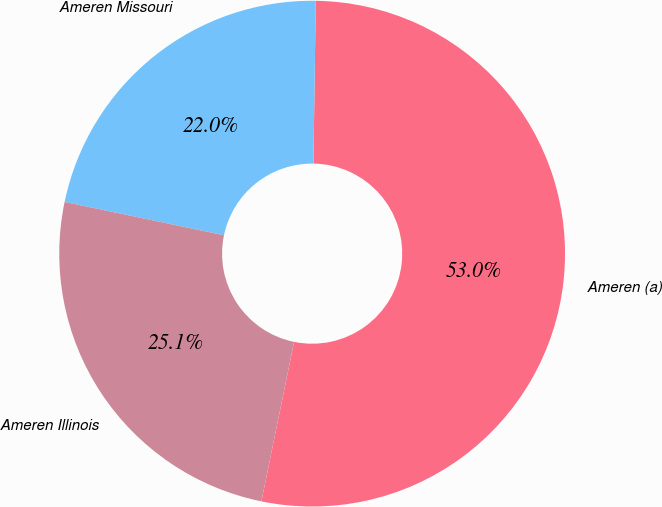Convert chart. <chart><loc_0><loc_0><loc_500><loc_500><pie_chart><fcel>Ameren (a)<fcel>Ameren Missouri<fcel>Ameren Illinois<nl><fcel>52.99%<fcel>21.95%<fcel>25.06%<nl></chart> 